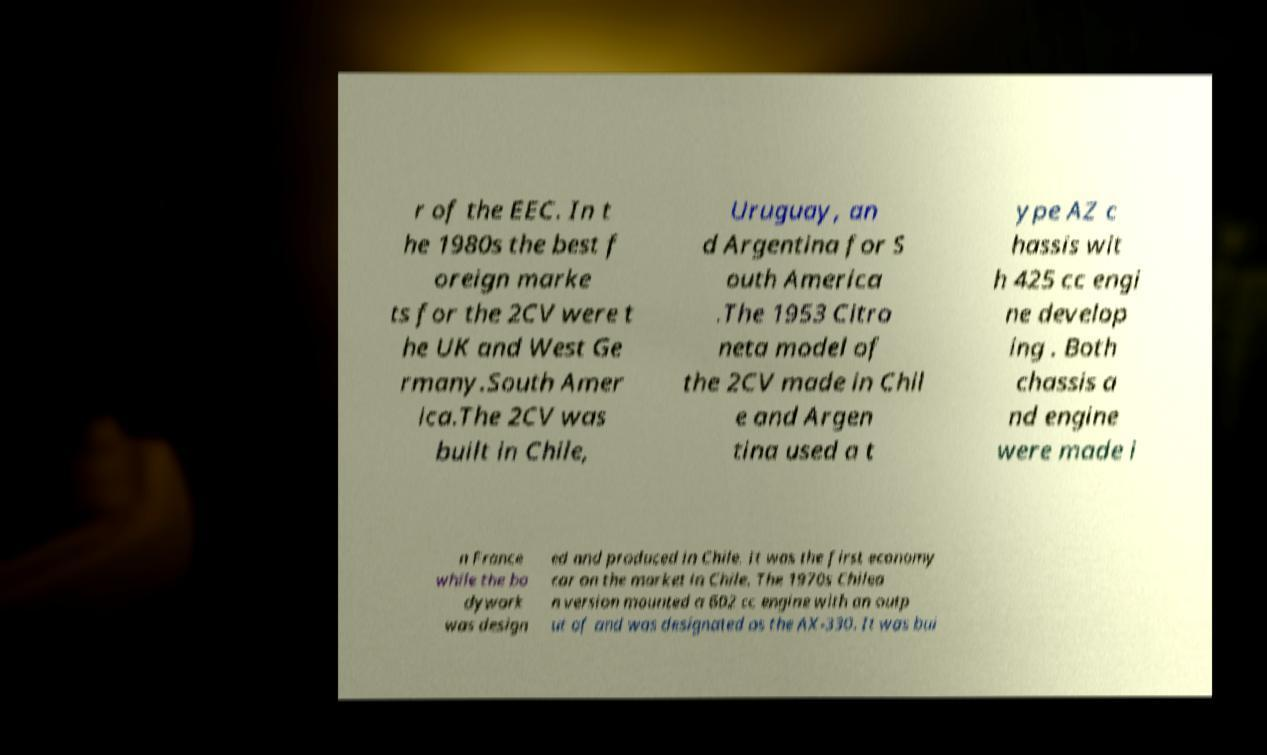There's text embedded in this image that I need extracted. Can you transcribe it verbatim? r of the EEC. In t he 1980s the best f oreign marke ts for the 2CV were t he UK and West Ge rmany.South Amer ica.The 2CV was built in Chile, Uruguay, an d Argentina for S outh America .The 1953 Citro neta model of the 2CV made in Chil e and Argen tina used a t ype AZ c hassis wit h 425 cc engi ne develop ing . Both chassis a nd engine were made i n France while the bo dywork was design ed and produced in Chile. It was the first economy car on the market in Chile. The 1970s Chilea n version mounted a 602 cc engine with an outp ut of and was designated as the AX-330. It was bui 